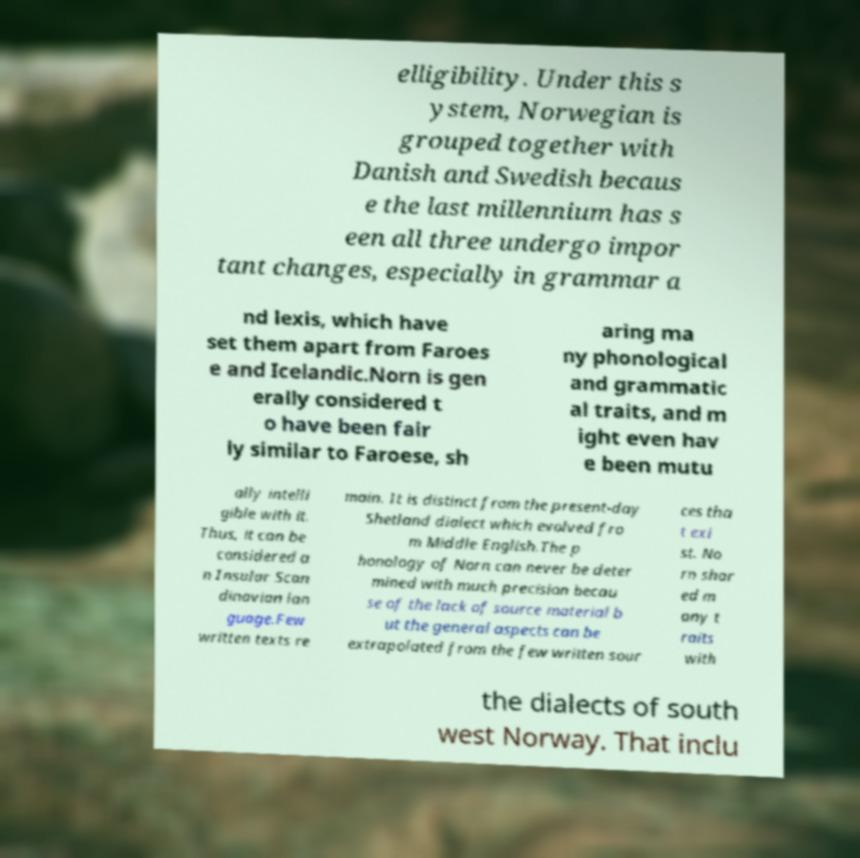I need the written content from this picture converted into text. Can you do that? elligibility. Under this s ystem, Norwegian is grouped together with Danish and Swedish becaus e the last millennium has s een all three undergo impor tant changes, especially in grammar a nd lexis, which have set them apart from Faroes e and Icelandic.Norn is gen erally considered t o have been fair ly similar to Faroese, sh aring ma ny phonological and grammatic al traits, and m ight even hav e been mutu ally intelli gible with it. Thus, it can be considered a n Insular Scan dinavian lan guage.Few written texts re main. It is distinct from the present-day Shetland dialect which evolved fro m Middle English.The p honology of Norn can never be deter mined with much precision becau se of the lack of source material b ut the general aspects can be extrapolated from the few written sour ces tha t exi st. No rn shar ed m any t raits with the dialects of south west Norway. That inclu 